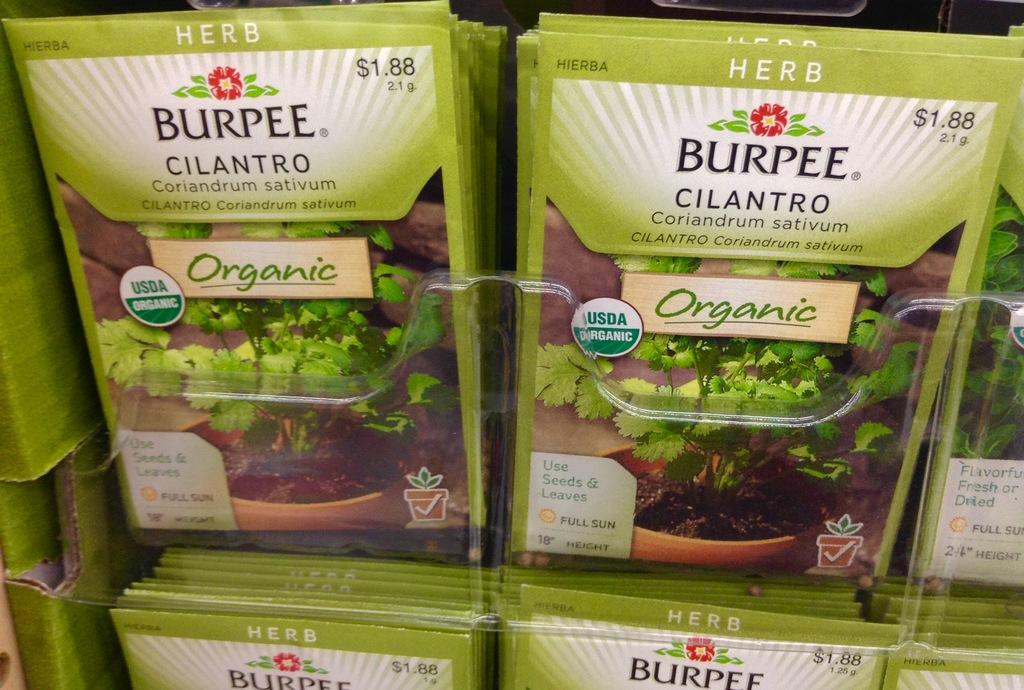What type of seeds are present in the image? There are cilantro seeds in the image. How are the cilantro seeds packaged? The cilantro seeds are in packets. What type of cushion is visible in the image? There is no cushion present in the image. Is the veil used to cover the cilantro seeds in the image? There is no veil present in the image, and the cilantro seeds are in packets, not covered by a veil. 